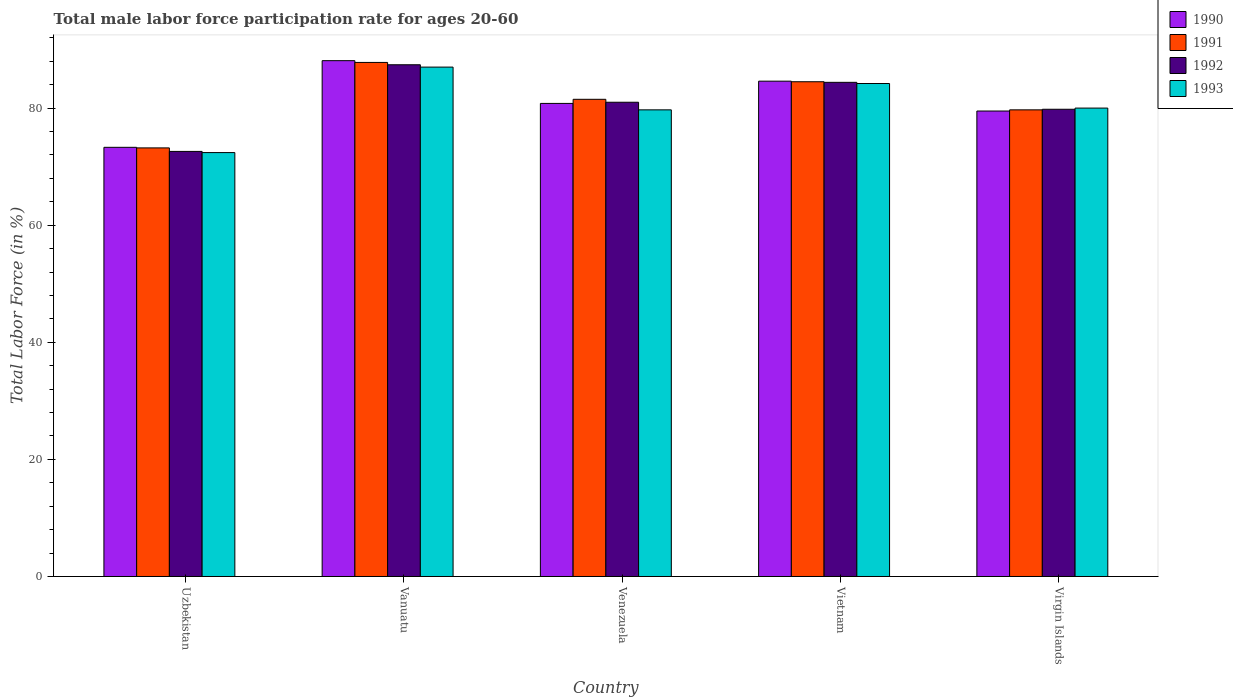Are the number of bars on each tick of the X-axis equal?
Give a very brief answer. Yes. How many bars are there on the 5th tick from the left?
Give a very brief answer. 4. How many bars are there on the 3rd tick from the right?
Ensure brevity in your answer.  4. What is the label of the 1st group of bars from the left?
Provide a succinct answer. Uzbekistan. In how many cases, is the number of bars for a given country not equal to the number of legend labels?
Provide a short and direct response. 0. What is the male labor force participation rate in 1990 in Vietnam?
Offer a terse response. 84.6. Across all countries, what is the maximum male labor force participation rate in 1990?
Give a very brief answer. 88.1. Across all countries, what is the minimum male labor force participation rate in 1991?
Give a very brief answer. 73.2. In which country was the male labor force participation rate in 1993 maximum?
Offer a very short reply. Vanuatu. In which country was the male labor force participation rate in 1991 minimum?
Your answer should be compact. Uzbekistan. What is the total male labor force participation rate in 1990 in the graph?
Your response must be concise. 406.3. What is the difference between the male labor force participation rate in 1991 in Vietnam and that in Virgin Islands?
Your answer should be compact. 4.8. What is the difference between the male labor force participation rate in 1991 in Vietnam and the male labor force participation rate in 1992 in Vanuatu?
Your response must be concise. -2.9. What is the average male labor force participation rate in 1993 per country?
Provide a short and direct response. 80.66. What is the difference between the male labor force participation rate of/in 1991 and male labor force participation rate of/in 1992 in Venezuela?
Make the answer very short. 0.5. What is the ratio of the male labor force participation rate in 1991 in Venezuela to that in Vietnam?
Offer a terse response. 0.96. Is the difference between the male labor force participation rate in 1991 in Venezuela and Virgin Islands greater than the difference between the male labor force participation rate in 1992 in Venezuela and Virgin Islands?
Offer a very short reply. Yes. What is the difference between the highest and the second highest male labor force participation rate in 1992?
Offer a very short reply. -3.4. What is the difference between the highest and the lowest male labor force participation rate in 1991?
Your answer should be very brief. 14.6. Is the sum of the male labor force participation rate in 1990 in Uzbekistan and Virgin Islands greater than the maximum male labor force participation rate in 1991 across all countries?
Give a very brief answer. Yes. Is it the case that in every country, the sum of the male labor force participation rate in 1992 and male labor force participation rate in 1991 is greater than the sum of male labor force participation rate in 1993 and male labor force participation rate in 1990?
Give a very brief answer. No. What does the 3rd bar from the left in Vanuatu represents?
Your answer should be very brief. 1992. Are all the bars in the graph horizontal?
Give a very brief answer. No. What is the difference between two consecutive major ticks on the Y-axis?
Make the answer very short. 20. Where does the legend appear in the graph?
Give a very brief answer. Top right. What is the title of the graph?
Make the answer very short. Total male labor force participation rate for ages 20-60. Does "2000" appear as one of the legend labels in the graph?
Provide a short and direct response. No. What is the label or title of the X-axis?
Provide a short and direct response. Country. What is the label or title of the Y-axis?
Your response must be concise. Total Labor Force (in %). What is the Total Labor Force (in %) in 1990 in Uzbekistan?
Make the answer very short. 73.3. What is the Total Labor Force (in %) of 1991 in Uzbekistan?
Keep it short and to the point. 73.2. What is the Total Labor Force (in %) of 1992 in Uzbekistan?
Keep it short and to the point. 72.6. What is the Total Labor Force (in %) of 1993 in Uzbekistan?
Make the answer very short. 72.4. What is the Total Labor Force (in %) of 1990 in Vanuatu?
Your response must be concise. 88.1. What is the Total Labor Force (in %) in 1991 in Vanuatu?
Your answer should be compact. 87.8. What is the Total Labor Force (in %) in 1992 in Vanuatu?
Your answer should be very brief. 87.4. What is the Total Labor Force (in %) in 1993 in Vanuatu?
Offer a very short reply. 87. What is the Total Labor Force (in %) of 1990 in Venezuela?
Offer a terse response. 80.8. What is the Total Labor Force (in %) of 1991 in Venezuela?
Keep it short and to the point. 81.5. What is the Total Labor Force (in %) in 1992 in Venezuela?
Offer a terse response. 81. What is the Total Labor Force (in %) of 1993 in Venezuela?
Your answer should be very brief. 79.7. What is the Total Labor Force (in %) in 1990 in Vietnam?
Provide a succinct answer. 84.6. What is the Total Labor Force (in %) of 1991 in Vietnam?
Ensure brevity in your answer.  84.5. What is the Total Labor Force (in %) of 1992 in Vietnam?
Offer a terse response. 84.4. What is the Total Labor Force (in %) in 1993 in Vietnam?
Your answer should be very brief. 84.2. What is the Total Labor Force (in %) in 1990 in Virgin Islands?
Make the answer very short. 79.5. What is the Total Labor Force (in %) of 1991 in Virgin Islands?
Make the answer very short. 79.7. What is the Total Labor Force (in %) of 1992 in Virgin Islands?
Your answer should be compact. 79.8. What is the Total Labor Force (in %) of 1993 in Virgin Islands?
Provide a succinct answer. 80. Across all countries, what is the maximum Total Labor Force (in %) in 1990?
Offer a very short reply. 88.1. Across all countries, what is the maximum Total Labor Force (in %) of 1991?
Provide a succinct answer. 87.8. Across all countries, what is the maximum Total Labor Force (in %) in 1992?
Your response must be concise. 87.4. Across all countries, what is the maximum Total Labor Force (in %) in 1993?
Keep it short and to the point. 87. Across all countries, what is the minimum Total Labor Force (in %) in 1990?
Give a very brief answer. 73.3. Across all countries, what is the minimum Total Labor Force (in %) of 1991?
Your response must be concise. 73.2. Across all countries, what is the minimum Total Labor Force (in %) of 1992?
Your response must be concise. 72.6. Across all countries, what is the minimum Total Labor Force (in %) of 1993?
Make the answer very short. 72.4. What is the total Total Labor Force (in %) of 1990 in the graph?
Make the answer very short. 406.3. What is the total Total Labor Force (in %) in 1991 in the graph?
Your response must be concise. 406.7. What is the total Total Labor Force (in %) of 1992 in the graph?
Offer a terse response. 405.2. What is the total Total Labor Force (in %) of 1993 in the graph?
Ensure brevity in your answer.  403.3. What is the difference between the Total Labor Force (in %) in 1990 in Uzbekistan and that in Vanuatu?
Provide a short and direct response. -14.8. What is the difference between the Total Labor Force (in %) in 1991 in Uzbekistan and that in Vanuatu?
Offer a terse response. -14.6. What is the difference between the Total Labor Force (in %) in 1992 in Uzbekistan and that in Vanuatu?
Provide a succinct answer. -14.8. What is the difference between the Total Labor Force (in %) of 1993 in Uzbekistan and that in Vanuatu?
Your answer should be compact. -14.6. What is the difference between the Total Labor Force (in %) in 1990 in Uzbekistan and that in Venezuela?
Ensure brevity in your answer.  -7.5. What is the difference between the Total Labor Force (in %) of 1993 in Uzbekistan and that in Venezuela?
Your answer should be very brief. -7.3. What is the difference between the Total Labor Force (in %) in 1990 in Uzbekistan and that in Vietnam?
Keep it short and to the point. -11.3. What is the difference between the Total Labor Force (in %) in 1991 in Uzbekistan and that in Vietnam?
Your answer should be very brief. -11.3. What is the difference between the Total Labor Force (in %) in 1992 in Uzbekistan and that in Vietnam?
Offer a terse response. -11.8. What is the difference between the Total Labor Force (in %) in 1993 in Uzbekistan and that in Vietnam?
Ensure brevity in your answer.  -11.8. What is the difference between the Total Labor Force (in %) in 1990 in Uzbekistan and that in Virgin Islands?
Provide a succinct answer. -6.2. What is the difference between the Total Labor Force (in %) of 1991 in Uzbekistan and that in Virgin Islands?
Make the answer very short. -6.5. What is the difference between the Total Labor Force (in %) in 1993 in Uzbekistan and that in Virgin Islands?
Provide a succinct answer. -7.6. What is the difference between the Total Labor Force (in %) in 1993 in Vanuatu and that in Venezuela?
Keep it short and to the point. 7.3. What is the difference between the Total Labor Force (in %) in 1993 in Vanuatu and that in Vietnam?
Offer a very short reply. 2.8. What is the difference between the Total Labor Force (in %) of 1990 in Vanuatu and that in Virgin Islands?
Provide a short and direct response. 8.6. What is the difference between the Total Labor Force (in %) of 1992 in Vanuatu and that in Virgin Islands?
Make the answer very short. 7.6. What is the difference between the Total Labor Force (in %) of 1993 in Vanuatu and that in Virgin Islands?
Offer a very short reply. 7. What is the difference between the Total Labor Force (in %) in 1990 in Venezuela and that in Vietnam?
Provide a succinct answer. -3.8. What is the difference between the Total Labor Force (in %) in 1992 in Venezuela and that in Vietnam?
Your response must be concise. -3.4. What is the difference between the Total Labor Force (in %) in 1992 in Venezuela and that in Virgin Islands?
Provide a short and direct response. 1.2. What is the difference between the Total Labor Force (in %) of 1993 in Venezuela and that in Virgin Islands?
Your answer should be very brief. -0.3. What is the difference between the Total Labor Force (in %) of 1991 in Vietnam and that in Virgin Islands?
Your response must be concise. 4.8. What is the difference between the Total Labor Force (in %) of 1992 in Vietnam and that in Virgin Islands?
Give a very brief answer. 4.6. What is the difference between the Total Labor Force (in %) in 1990 in Uzbekistan and the Total Labor Force (in %) in 1991 in Vanuatu?
Make the answer very short. -14.5. What is the difference between the Total Labor Force (in %) of 1990 in Uzbekistan and the Total Labor Force (in %) of 1992 in Vanuatu?
Ensure brevity in your answer.  -14.1. What is the difference between the Total Labor Force (in %) of 1990 in Uzbekistan and the Total Labor Force (in %) of 1993 in Vanuatu?
Offer a terse response. -13.7. What is the difference between the Total Labor Force (in %) of 1991 in Uzbekistan and the Total Labor Force (in %) of 1993 in Vanuatu?
Your answer should be compact. -13.8. What is the difference between the Total Labor Force (in %) in 1992 in Uzbekistan and the Total Labor Force (in %) in 1993 in Vanuatu?
Your answer should be very brief. -14.4. What is the difference between the Total Labor Force (in %) of 1990 in Uzbekistan and the Total Labor Force (in %) of 1991 in Venezuela?
Offer a very short reply. -8.2. What is the difference between the Total Labor Force (in %) in 1990 in Uzbekistan and the Total Labor Force (in %) in 1993 in Venezuela?
Offer a very short reply. -6.4. What is the difference between the Total Labor Force (in %) in 1991 in Uzbekistan and the Total Labor Force (in %) in 1992 in Venezuela?
Offer a very short reply. -7.8. What is the difference between the Total Labor Force (in %) in 1991 in Uzbekistan and the Total Labor Force (in %) in 1993 in Venezuela?
Your answer should be compact. -6.5. What is the difference between the Total Labor Force (in %) in 1990 in Uzbekistan and the Total Labor Force (in %) in 1992 in Vietnam?
Your answer should be very brief. -11.1. What is the difference between the Total Labor Force (in %) of 1990 in Uzbekistan and the Total Labor Force (in %) of 1993 in Vietnam?
Ensure brevity in your answer.  -10.9. What is the difference between the Total Labor Force (in %) of 1992 in Uzbekistan and the Total Labor Force (in %) of 1993 in Vietnam?
Offer a terse response. -11.6. What is the difference between the Total Labor Force (in %) in 1990 in Uzbekistan and the Total Labor Force (in %) in 1991 in Virgin Islands?
Provide a succinct answer. -6.4. What is the difference between the Total Labor Force (in %) of 1990 in Uzbekistan and the Total Labor Force (in %) of 1992 in Virgin Islands?
Provide a succinct answer. -6.5. What is the difference between the Total Labor Force (in %) in 1991 in Uzbekistan and the Total Labor Force (in %) in 1993 in Virgin Islands?
Your answer should be very brief. -6.8. What is the difference between the Total Labor Force (in %) in 1992 in Uzbekistan and the Total Labor Force (in %) in 1993 in Virgin Islands?
Offer a terse response. -7.4. What is the difference between the Total Labor Force (in %) of 1990 in Vanuatu and the Total Labor Force (in %) of 1991 in Venezuela?
Offer a very short reply. 6.6. What is the difference between the Total Labor Force (in %) in 1990 in Vanuatu and the Total Labor Force (in %) in 1993 in Venezuela?
Your answer should be very brief. 8.4. What is the difference between the Total Labor Force (in %) of 1990 in Vanuatu and the Total Labor Force (in %) of 1991 in Vietnam?
Give a very brief answer. 3.6. What is the difference between the Total Labor Force (in %) of 1990 in Vanuatu and the Total Labor Force (in %) of 1993 in Vietnam?
Your answer should be very brief. 3.9. What is the difference between the Total Labor Force (in %) in 1991 in Vanuatu and the Total Labor Force (in %) in 1993 in Vietnam?
Offer a terse response. 3.6. What is the difference between the Total Labor Force (in %) of 1990 in Vanuatu and the Total Labor Force (in %) of 1991 in Virgin Islands?
Your answer should be very brief. 8.4. What is the difference between the Total Labor Force (in %) in 1990 in Vanuatu and the Total Labor Force (in %) in 1992 in Virgin Islands?
Make the answer very short. 8.3. What is the difference between the Total Labor Force (in %) in 1990 in Vanuatu and the Total Labor Force (in %) in 1993 in Virgin Islands?
Make the answer very short. 8.1. What is the difference between the Total Labor Force (in %) of 1991 in Vanuatu and the Total Labor Force (in %) of 1993 in Virgin Islands?
Your answer should be very brief. 7.8. What is the difference between the Total Labor Force (in %) in 1990 in Venezuela and the Total Labor Force (in %) in 1991 in Vietnam?
Offer a terse response. -3.7. What is the difference between the Total Labor Force (in %) of 1990 in Venezuela and the Total Labor Force (in %) of 1992 in Vietnam?
Give a very brief answer. -3.6. What is the difference between the Total Labor Force (in %) of 1991 in Venezuela and the Total Labor Force (in %) of 1992 in Vietnam?
Offer a terse response. -2.9. What is the difference between the Total Labor Force (in %) in 1990 in Venezuela and the Total Labor Force (in %) in 1991 in Virgin Islands?
Ensure brevity in your answer.  1.1. What is the difference between the Total Labor Force (in %) of 1990 in Venezuela and the Total Labor Force (in %) of 1993 in Virgin Islands?
Your answer should be compact. 0.8. What is the difference between the Total Labor Force (in %) in 1992 in Venezuela and the Total Labor Force (in %) in 1993 in Virgin Islands?
Keep it short and to the point. 1. What is the difference between the Total Labor Force (in %) in 1990 in Vietnam and the Total Labor Force (in %) in 1993 in Virgin Islands?
Provide a succinct answer. 4.6. What is the difference between the Total Labor Force (in %) in 1992 in Vietnam and the Total Labor Force (in %) in 1993 in Virgin Islands?
Provide a succinct answer. 4.4. What is the average Total Labor Force (in %) in 1990 per country?
Offer a terse response. 81.26. What is the average Total Labor Force (in %) of 1991 per country?
Give a very brief answer. 81.34. What is the average Total Labor Force (in %) in 1992 per country?
Your answer should be compact. 81.04. What is the average Total Labor Force (in %) in 1993 per country?
Keep it short and to the point. 80.66. What is the difference between the Total Labor Force (in %) of 1990 and Total Labor Force (in %) of 1991 in Uzbekistan?
Ensure brevity in your answer.  0.1. What is the difference between the Total Labor Force (in %) of 1990 and Total Labor Force (in %) of 1992 in Uzbekistan?
Provide a succinct answer. 0.7. What is the difference between the Total Labor Force (in %) in 1990 and Total Labor Force (in %) in 1993 in Vanuatu?
Your response must be concise. 1.1. What is the difference between the Total Labor Force (in %) of 1991 and Total Labor Force (in %) of 1992 in Vanuatu?
Your answer should be compact. 0.4. What is the difference between the Total Labor Force (in %) in 1992 and Total Labor Force (in %) in 1993 in Vanuatu?
Make the answer very short. 0.4. What is the difference between the Total Labor Force (in %) in 1990 and Total Labor Force (in %) in 1991 in Venezuela?
Keep it short and to the point. -0.7. What is the difference between the Total Labor Force (in %) in 1991 and Total Labor Force (in %) in 1993 in Venezuela?
Provide a short and direct response. 1.8. What is the difference between the Total Labor Force (in %) in 1992 and Total Labor Force (in %) in 1993 in Venezuela?
Your answer should be compact. 1.3. What is the difference between the Total Labor Force (in %) in 1990 and Total Labor Force (in %) in 1992 in Vietnam?
Your answer should be very brief. 0.2. What is the difference between the Total Labor Force (in %) in 1991 and Total Labor Force (in %) in 1992 in Vietnam?
Ensure brevity in your answer.  0.1. What is the difference between the Total Labor Force (in %) in 1991 and Total Labor Force (in %) in 1993 in Vietnam?
Provide a short and direct response. 0.3. What is the difference between the Total Labor Force (in %) of 1992 and Total Labor Force (in %) of 1993 in Vietnam?
Make the answer very short. 0.2. What is the difference between the Total Labor Force (in %) in 1990 and Total Labor Force (in %) in 1992 in Virgin Islands?
Offer a very short reply. -0.3. What is the difference between the Total Labor Force (in %) of 1990 and Total Labor Force (in %) of 1993 in Virgin Islands?
Offer a terse response. -0.5. What is the difference between the Total Labor Force (in %) of 1991 and Total Labor Force (in %) of 1992 in Virgin Islands?
Ensure brevity in your answer.  -0.1. What is the ratio of the Total Labor Force (in %) of 1990 in Uzbekistan to that in Vanuatu?
Provide a short and direct response. 0.83. What is the ratio of the Total Labor Force (in %) in 1991 in Uzbekistan to that in Vanuatu?
Your answer should be compact. 0.83. What is the ratio of the Total Labor Force (in %) of 1992 in Uzbekistan to that in Vanuatu?
Make the answer very short. 0.83. What is the ratio of the Total Labor Force (in %) of 1993 in Uzbekistan to that in Vanuatu?
Your response must be concise. 0.83. What is the ratio of the Total Labor Force (in %) in 1990 in Uzbekistan to that in Venezuela?
Your answer should be very brief. 0.91. What is the ratio of the Total Labor Force (in %) in 1991 in Uzbekistan to that in Venezuela?
Give a very brief answer. 0.9. What is the ratio of the Total Labor Force (in %) in 1992 in Uzbekistan to that in Venezuela?
Your answer should be very brief. 0.9. What is the ratio of the Total Labor Force (in %) of 1993 in Uzbekistan to that in Venezuela?
Ensure brevity in your answer.  0.91. What is the ratio of the Total Labor Force (in %) of 1990 in Uzbekistan to that in Vietnam?
Provide a succinct answer. 0.87. What is the ratio of the Total Labor Force (in %) in 1991 in Uzbekistan to that in Vietnam?
Provide a short and direct response. 0.87. What is the ratio of the Total Labor Force (in %) of 1992 in Uzbekistan to that in Vietnam?
Your answer should be very brief. 0.86. What is the ratio of the Total Labor Force (in %) in 1993 in Uzbekistan to that in Vietnam?
Keep it short and to the point. 0.86. What is the ratio of the Total Labor Force (in %) of 1990 in Uzbekistan to that in Virgin Islands?
Offer a terse response. 0.92. What is the ratio of the Total Labor Force (in %) in 1991 in Uzbekistan to that in Virgin Islands?
Keep it short and to the point. 0.92. What is the ratio of the Total Labor Force (in %) in 1992 in Uzbekistan to that in Virgin Islands?
Make the answer very short. 0.91. What is the ratio of the Total Labor Force (in %) of 1993 in Uzbekistan to that in Virgin Islands?
Offer a terse response. 0.91. What is the ratio of the Total Labor Force (in %) of 1990 in Vanuatu to that in Venezuela?
Provide a succinct answer. 1.09. What is the ratio of the Total Labor Force (in %) in 1991 in Vanuatu to that in Venezuela?
Keep it short and to the point. 1.08. What is the ratio of the Total Labor Force (in %) of 1992 in Vanuatu to that in Venezuela?
Make the answer very short. 1.08. What is the ratio of the Total Labor Force (in %) of 1993 in Vanuatu to that in Venezuela?
Offer a terse response. 1.09. What is the ratio of the Total Labor Force (in %) of 1990 in Vanuatu to that in Vietnam?
Ensure brevity in your answer.  1.04. What is the ratio of the Total Labor Force (in %) in 1991 in Vanuatu to that in Vietnam?
Ensure brevity in your answer.  1.04. What is the ratio of the Total Labor Force (in %) in 1992 in Vanuatu to that in Vietnam?
Provide a short and direct response. 1.04. What is the ratio of the Total Labor Force (in %) of 1990 in Vanuatu to that in Virgin Islands?
Keep it short and to the point. 1.11. What is the ratio of the Total Labor Force (in %) in 1991 in Vanuatu to that in Virgin Islands?
Offer a very short reply. 1.1. What is the ratio of the Total Labor Force (in %) in 1992 in Vanuatu to that in Virgin Islands?
Provide a succinct answer. 1.1. What is the ratio of the Total Labor Force (in %) of 1993 in Vanuatu to that in Virgin Islands?
Offer a terse response. 1.09. What is the ratio of the Total Labor Force (in %) of 1990 in Venezuela to that in Vietnam?
Your answer should be very brief. 0.96. What is the ratio of the Total Labor Force (in %) of 1991 in Venezuela to that in Vietnam?
Your response must be concise. 0.96. What is the ratio of the Total Labor Force (in %) of 1992 in Venezuela to that in Vietnam?
Ensure brevity in your answer.  0.96. What is the ratio of the Total Labor Force (in %) of 1993 in Venezuela to that in Vietnam?
Provide a short and direct response. 0.95. What is the ratio of the Total Labor Force (in %) in 1990 in Venezuela to that in Virgin Islands?
Keep it short and to the point. 1.02. What is the ratio of the Total Labor Force (in %) of 1991 in Venezuela to that in Virgin Islands?
Your answer should be compact. 1.02. What is the ratio of the Total Labor Force (in %) of 1992 in Venezuela to that in Virgin Islands?
Make the answer very short. 1.01. What is the ratio of the Total Labor Force (in %) of 1990 in Vietnam to that in Virgin Islands?
Provide a succinct answer. 1.06. What is the ratio of the Total Labor Force (in %) in 1991 in Vietnam to that in Virgin Islands?
Offer a terse response. 1.06. What is the ratio of the Total Labor Force (in %) in 1992 in Vietnam to that in Virgin Islands?
Provide a succinct answer. 1.06. What is the ratio of the Total Labor Force (in %) in 1993 in Vietnam to that in Virgin Islands?
Your answer should be compact. 1.05. What is the difference between the highest and the second highest Total Labor Force (in %) in 1991?
Provide a succinct answer. 3.3. What is the difference between the highest and the second highest Total Labor Force (in %) in 1992?
Your answer should be very brief. 3. What is the difference between the highest and the lowest Total Labor Force (in %) in 1991?
Provide a succinct answer. 14.6. What is the difference between the highest and the lowest Total Labor Force (in %) of 1992?
Offer a very short reply. 14.8. 